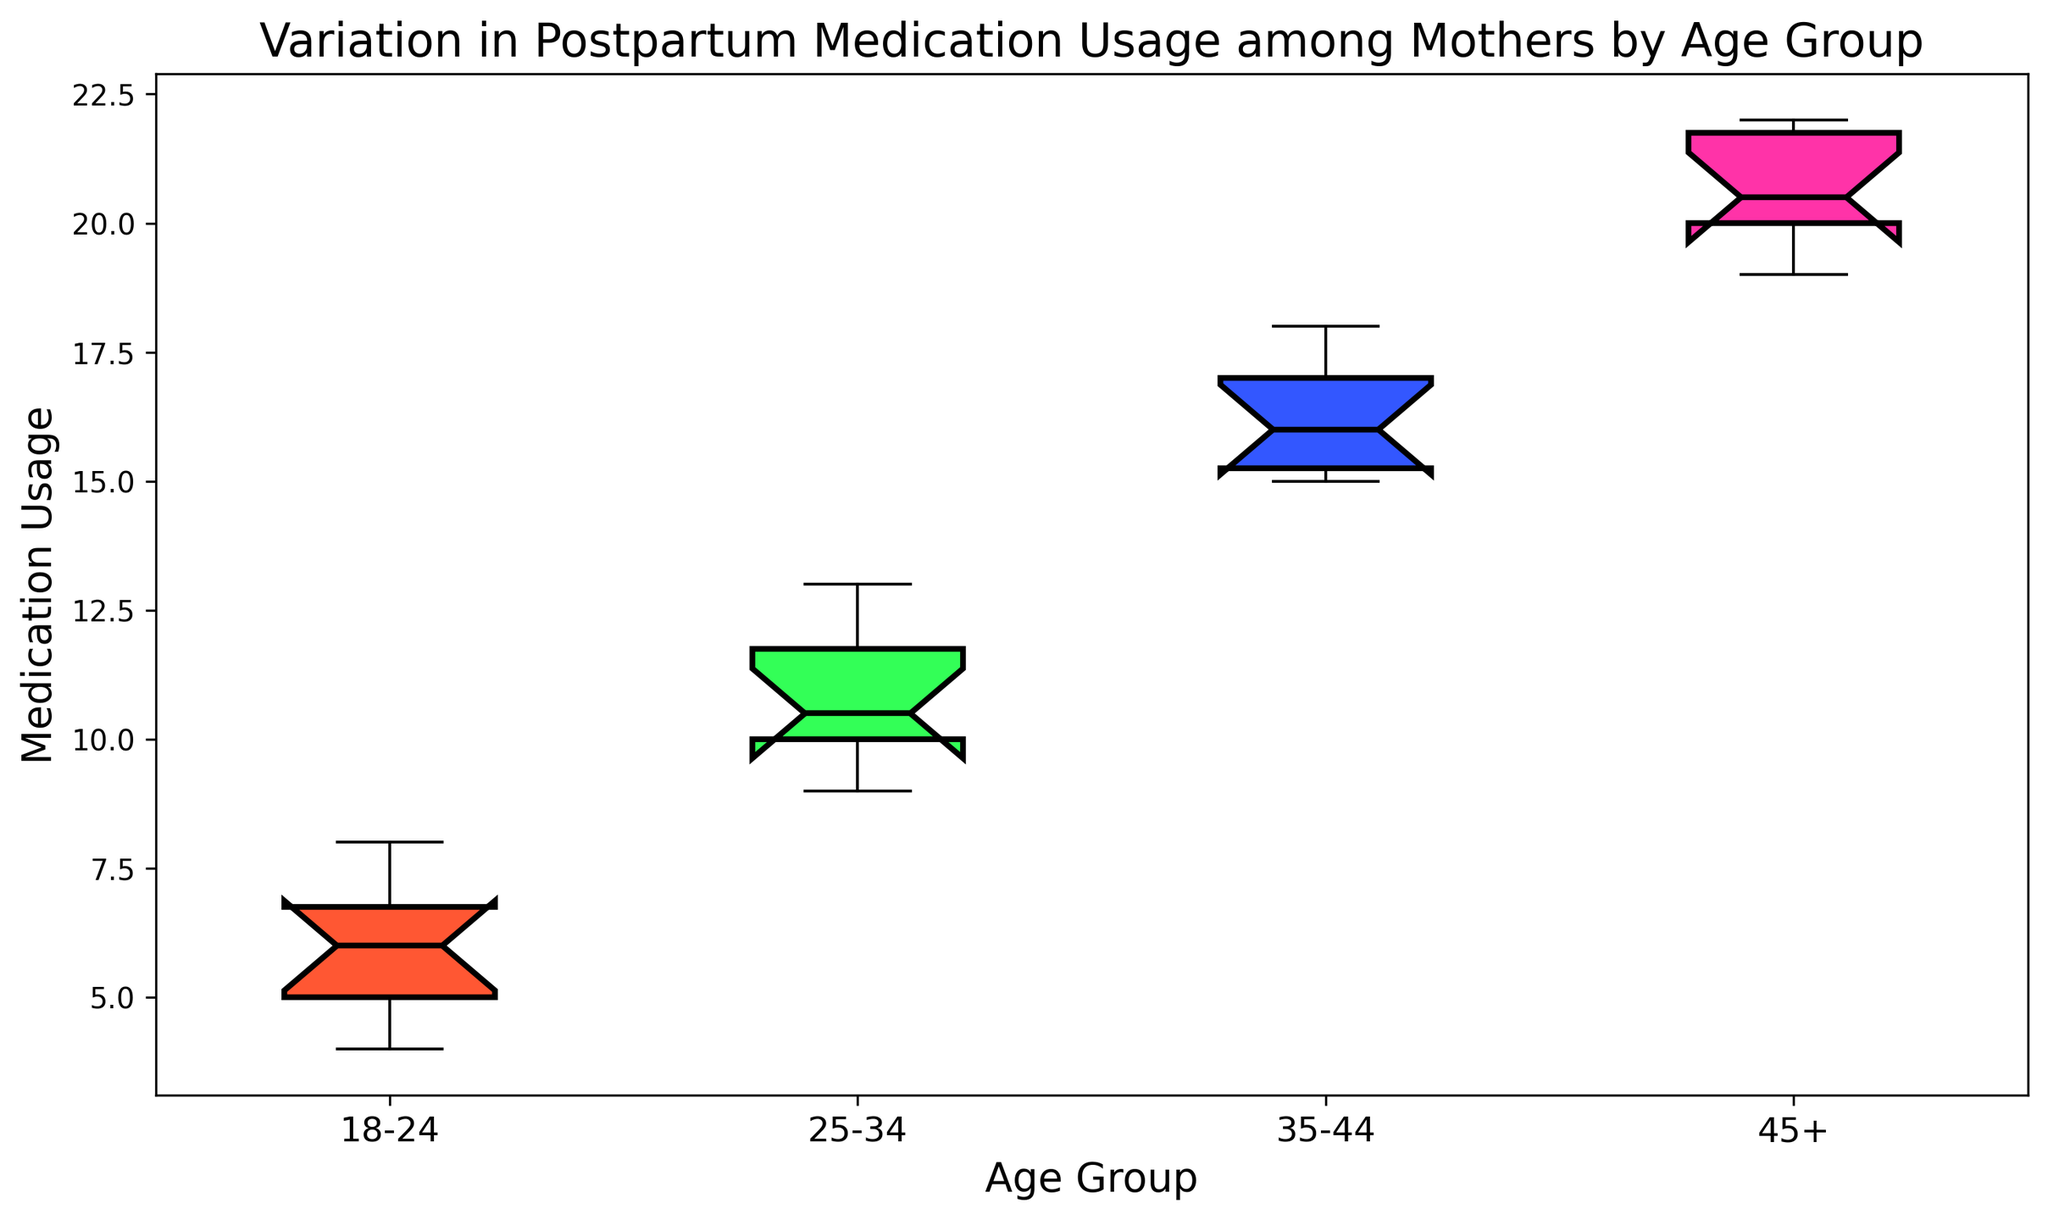Which age group has the highest median medication usage? By looking at the median lines inside each box, we can identify the highest median value. The 45+ age group has the highest median, located between 20 and 21.
Answer: 45+ Which age group has the lowest median medication usage? By examining the median lines inside each box, we see that the 18-24 age group has the lowest median value, positioned around 6.
Answer: 18-24 Is the interquartile range (IQR) larger for the 25-34 age group or the 35-44 age group? The IQR is the range between the first quartile (Q1) and the third quartile (Q3). By comparing the height of the boxes, we see the IQR for 25-34 (9 to 12) is slightly smaller than for 35-44 (15 to 17).
Answer: 35-44 Which age group's interquartile range spans from 5 to 7? The IQR for the 18-24 age group ranges from 5 to 7, as seen between the bottom and top edges of its box.
Answer: 18-24 Compare the range of medication usage between the 35-44 and 45+ age groups. Which is wider? The range is from the minimum to the maximum value. For the 35-44 age group, the range is from 15 to 18, while for the 45+ age group, it is from 19 to 22. Thus, 45+ is wider.
Answer: 45+ Which age group has the most consistent medication usage? Consistency is indicated by the smallest range and interquartile range. The 18-24 group appears to have the smallest range and IQR, indicating more consistency.
Answer: 18-24 Between the 18-24 and 25-34 age groups, which has a higher maximum medication usage? The highest usage value is the top whisker of the boxplot. For 18-24 it's 8, and for 25-34 it's 13. Therefore, 25-34 has a higher maximum.
Answer: 25-34 Is there more variation in medication usage in the 45+ age group compared to the 35-44 age group? Variation can be observed by looking at the overall range and IQR. The 45+ group has both a larger range (19 to 22) and IQR compared to the 35-44 group (15 to 18).
Answer: Yes 